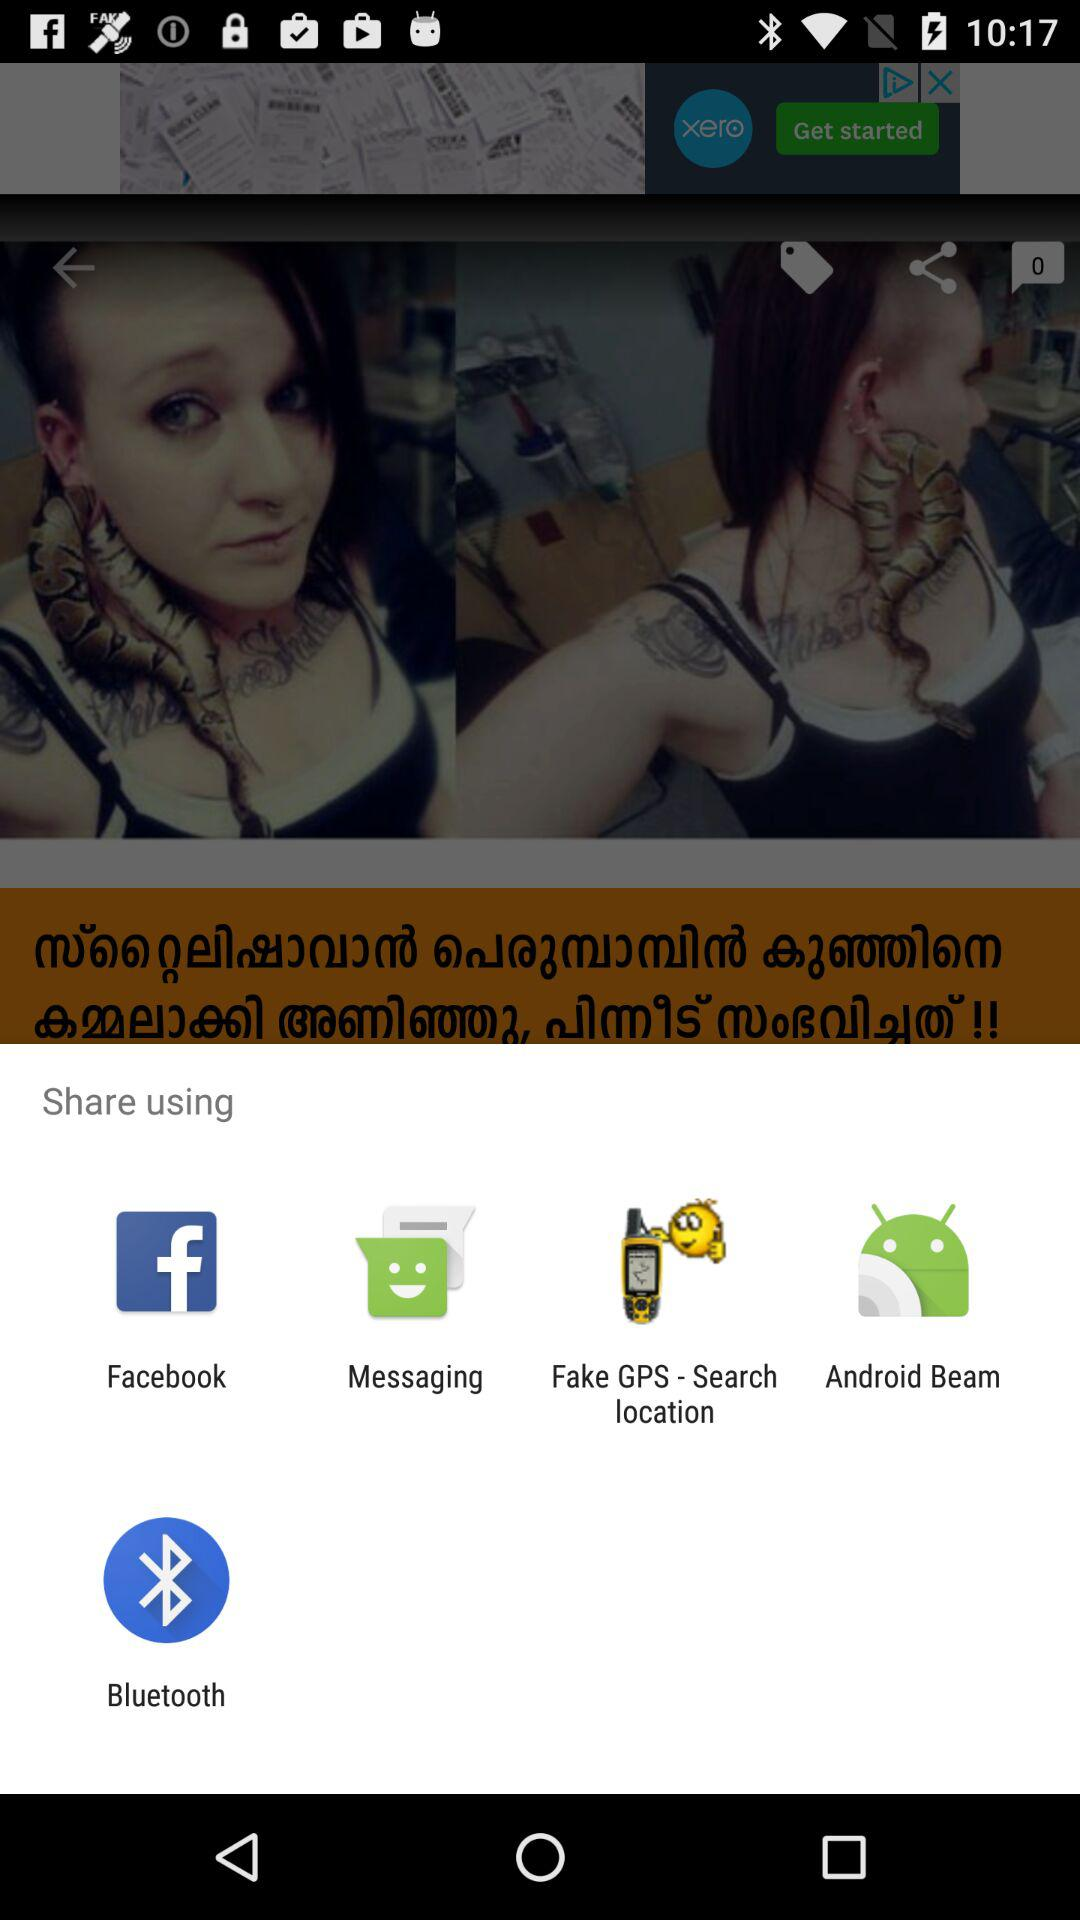How many likes did the image get?
When the provided information is insufficient, respond with <no answer>. <no answer> 